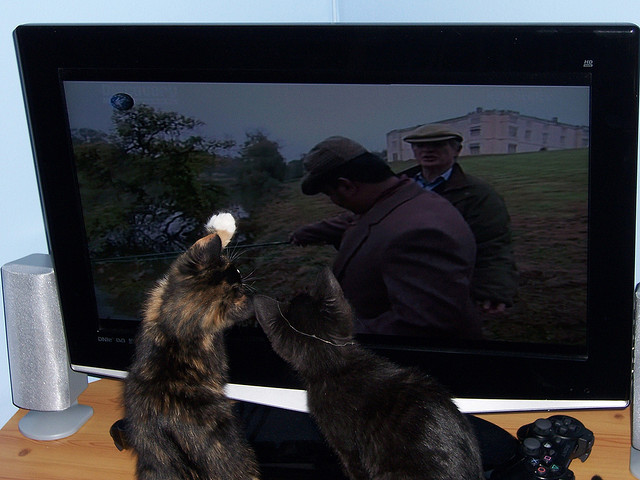<image>What kind of stuffed animals are there? There are no stuffed animals in the image, however, there may be a bear or cats. What kind of stuffed animals are there? There are no stuffed animals in the image. 